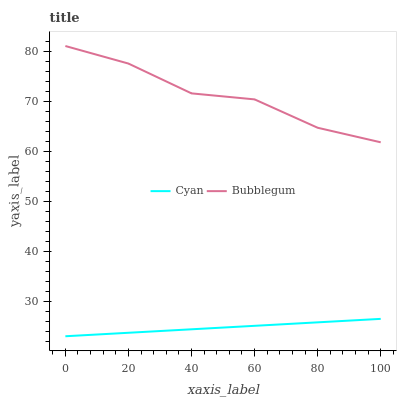Does Cyan have the minimum area under the curve?
Answer yes or no. Yes. Does Bubblegum have the maximum area under the curve?
Answer yes or no. Yes. Does Bubblegum have the minimum area under the curve?
Answer yes or no. No. Is Cyan the smoothest?
Answer yes or no. Yes. Is Bubblegum the roughest?
Answer yes or no. Yes. Is Bubblegum the smoothest?
Answer yes or no. No. Does Cyan have the lowest value?
Answer yes or no. Yes. Does Bubblegum have the lowest value?
Answer yes or no. No. Does Bubblegum have the highest value?
Answer yes or no. Yes. Is Cyan less than Bubblegum?
Answer yes or no. Yes. Is Bubblegum greater than Cyan?
Answer yes or no. Yes. Does Cyan intersect Bubblegum?
Answer yes or no. No. 